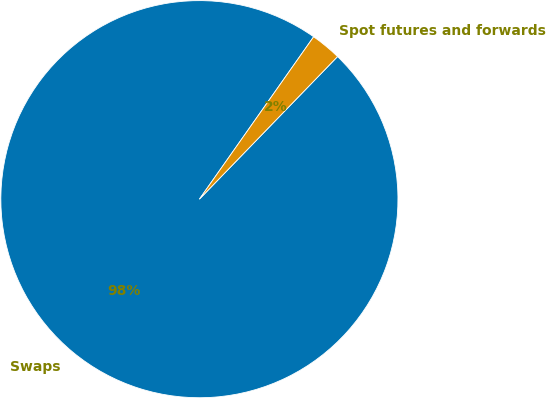<chart> <loc_0><loc_0><loc_500><loc_500><pie_chart><fcel>Swaps<fcel>Spot futures and forwards<nl><fcel>97.51%<fcel>2.49%<nl></chart> 